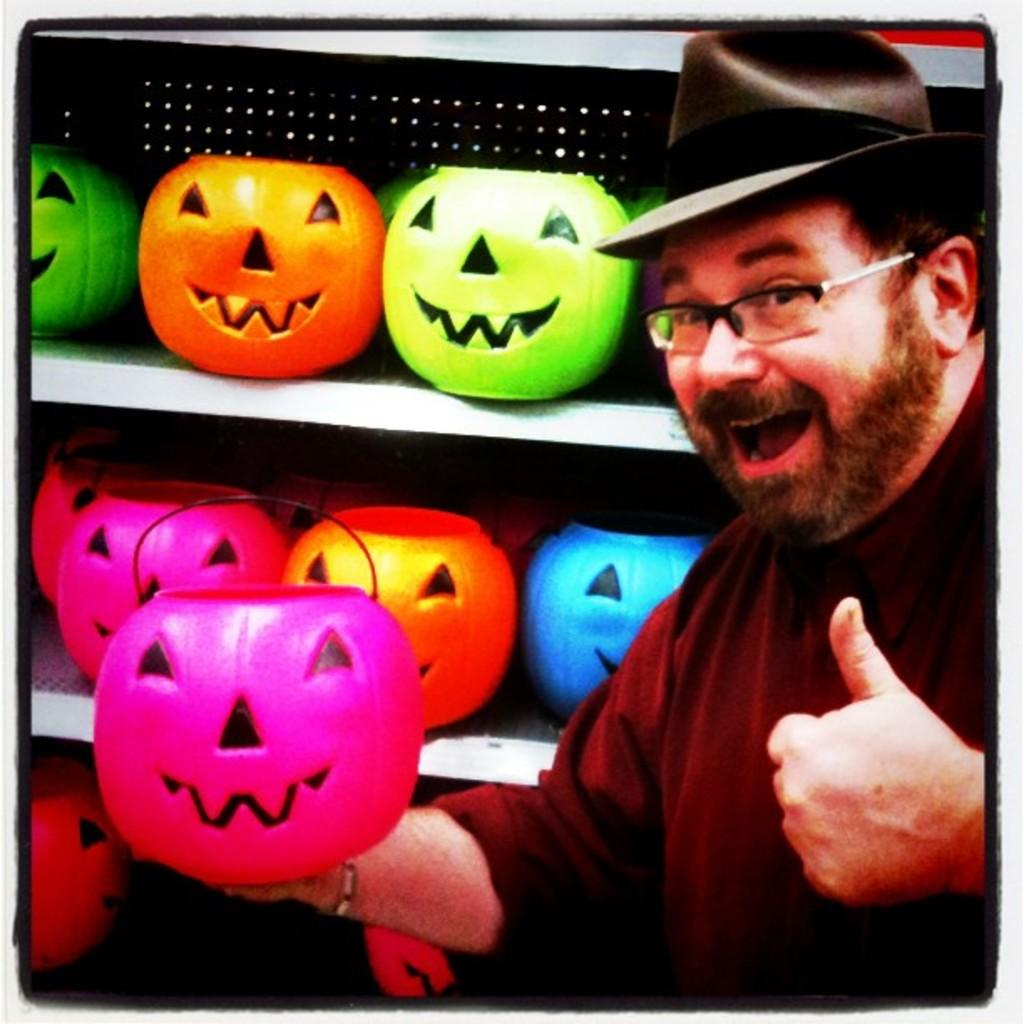What can be seen in the image? There is a person in the image. What is the person wearing? The person is wearing a pink t-shirt and a black hat. What is the person holding? The person is holding a pink pumpkin. What can be seen in the background? There are other pumpkins in the background, which are in racks. What type of society is depicted in the image? The image does not depict a society; it features a person holding a pink pumpkin and other pumpkins in the background. How does the person feel about the pumpkins in the image? The image does not convey the person's feelings about the pumpkins; it only shows them holding a pink pumpkin and other pumpkins in the background. 